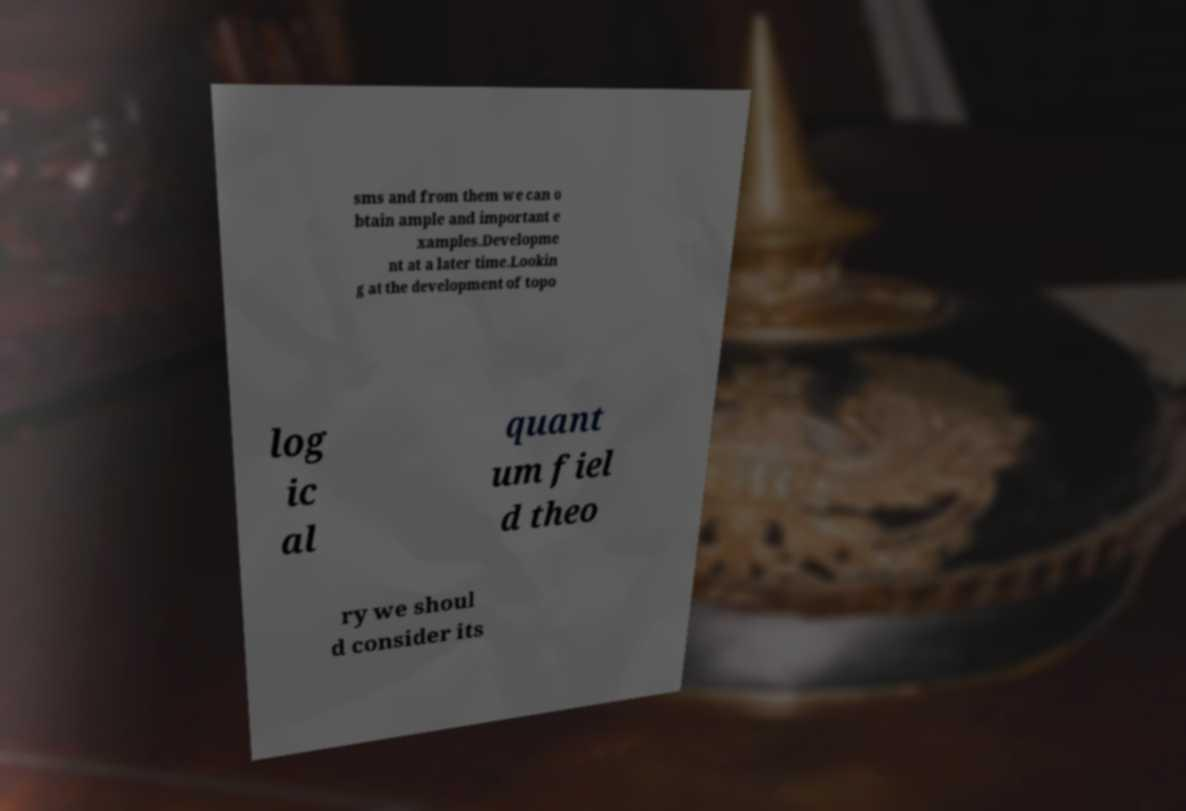Please identify and transcribe the text found in this image. sms and from them we can o btain ample and important e xamples.Developme nt at a later time.Lookin g at the development of topo log ic al quant um fiel d theo ry we shoul d consider its 